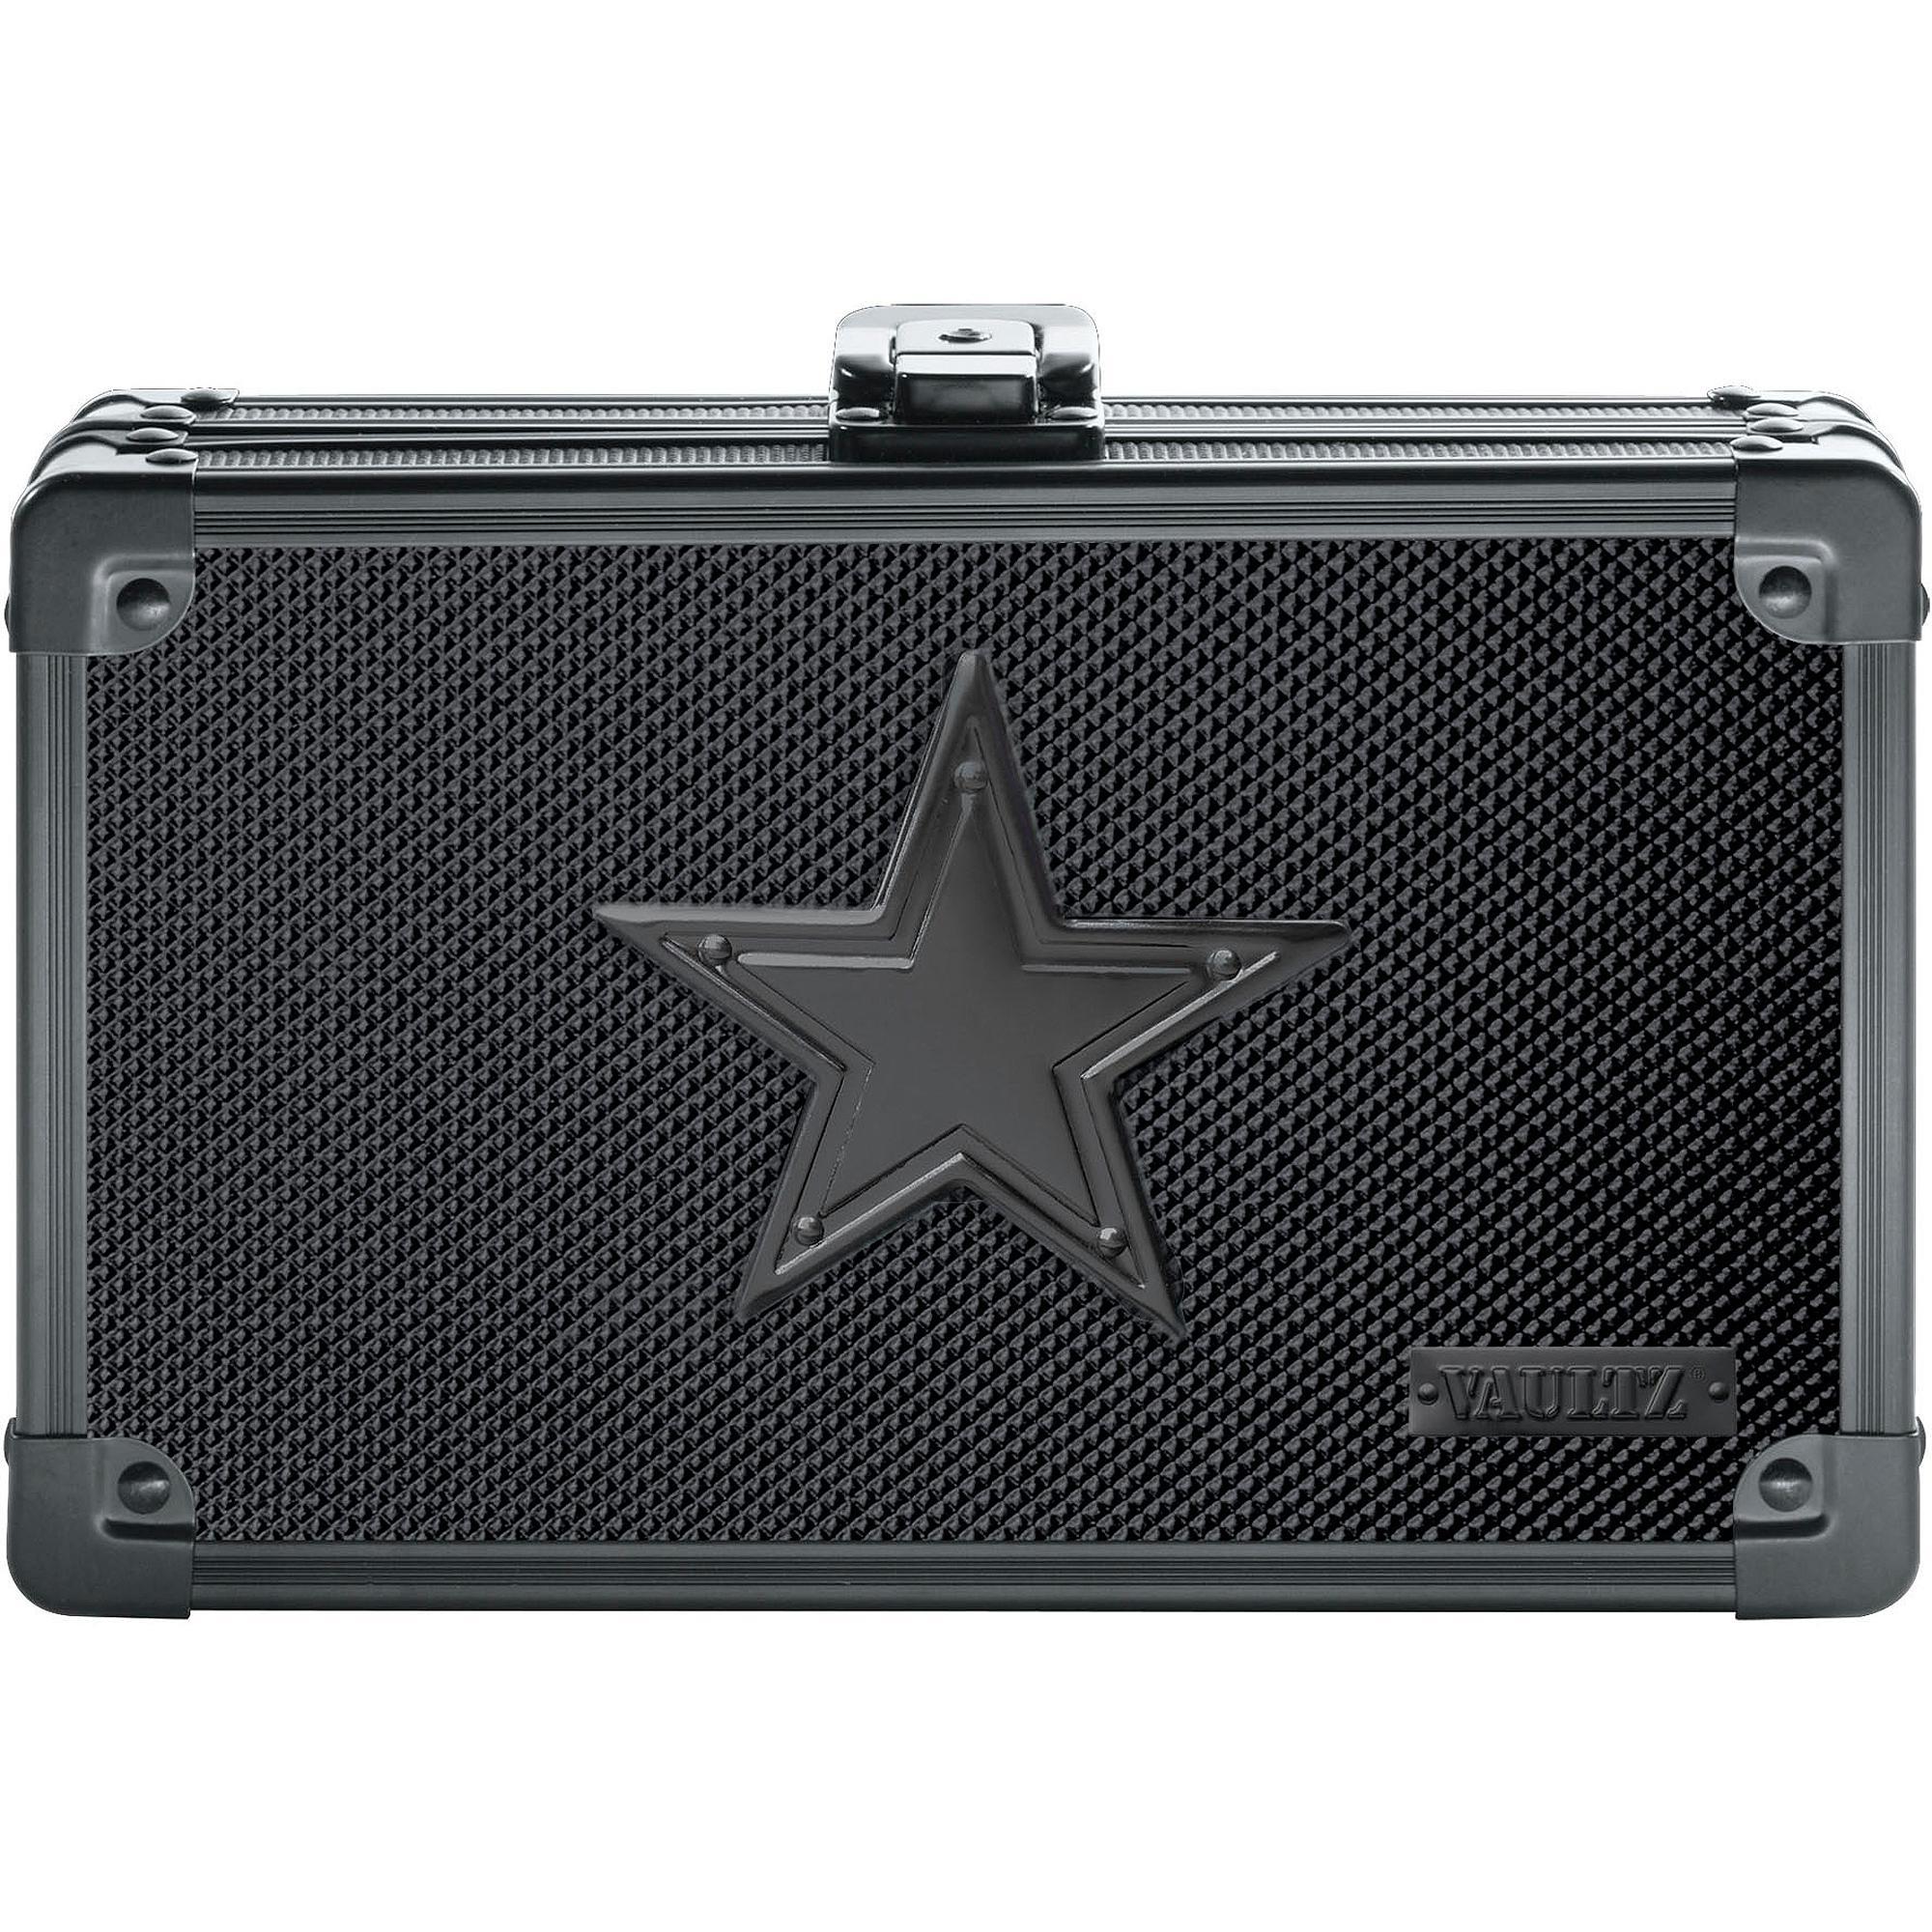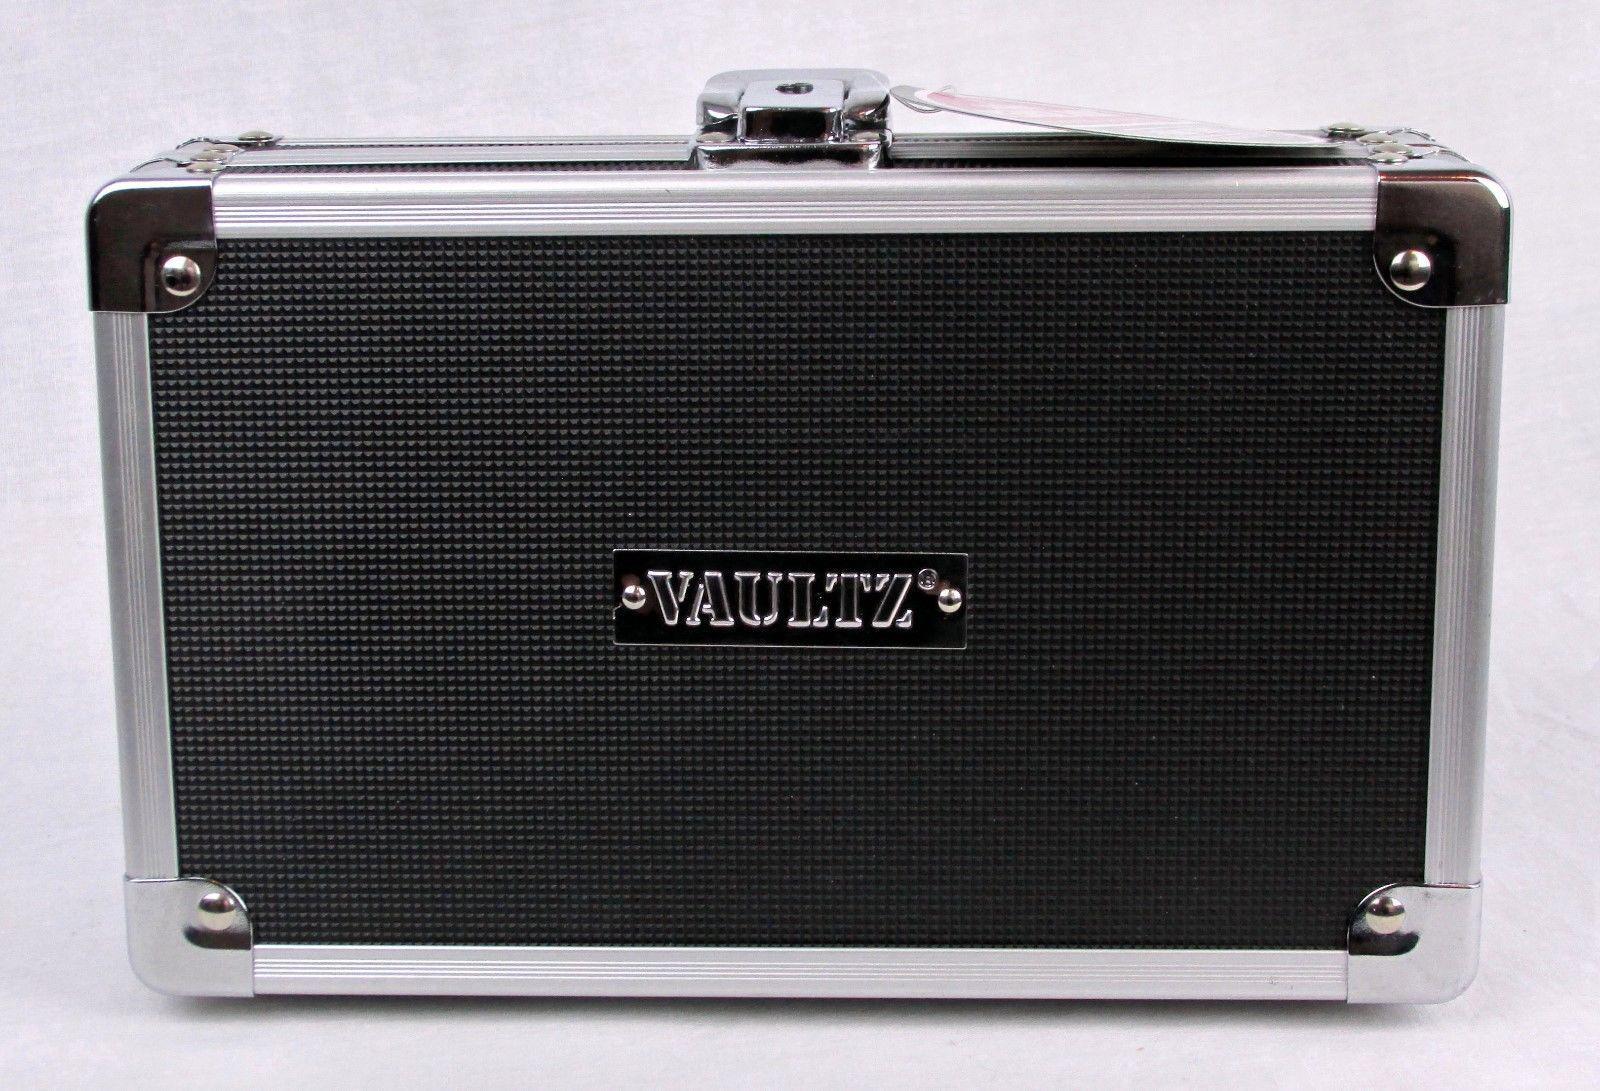The first image is the image on the left, the second image is the image on the right. For the images shown, is this caption "There is a batman logo." true? Answer yes or no. No. The first image is the image on the left, the second image is the image on the right. For the images shown, is this caption "In one of the images there is a suitcase that is sitting at a 45 degree angle." true? Answer yes or no. No. 